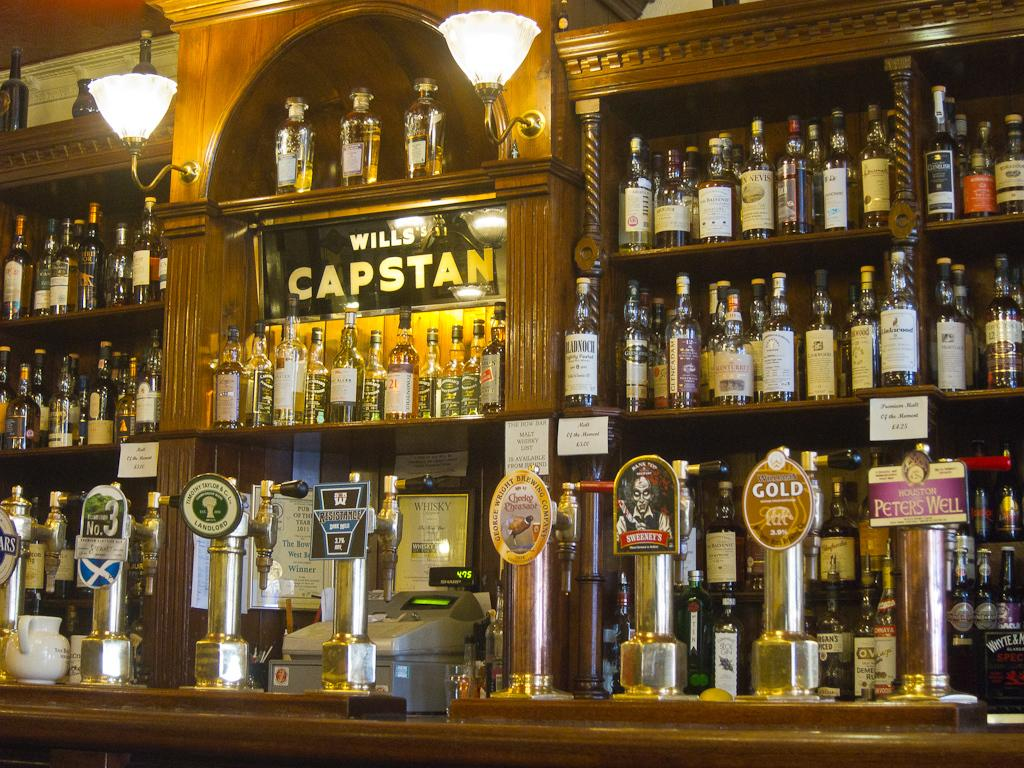Provide a one-sentence caption for the provided image. Old fashioned wooden bar with multiple liquor bottles and beer taps with the name Wills's Capstan on the mirror. 